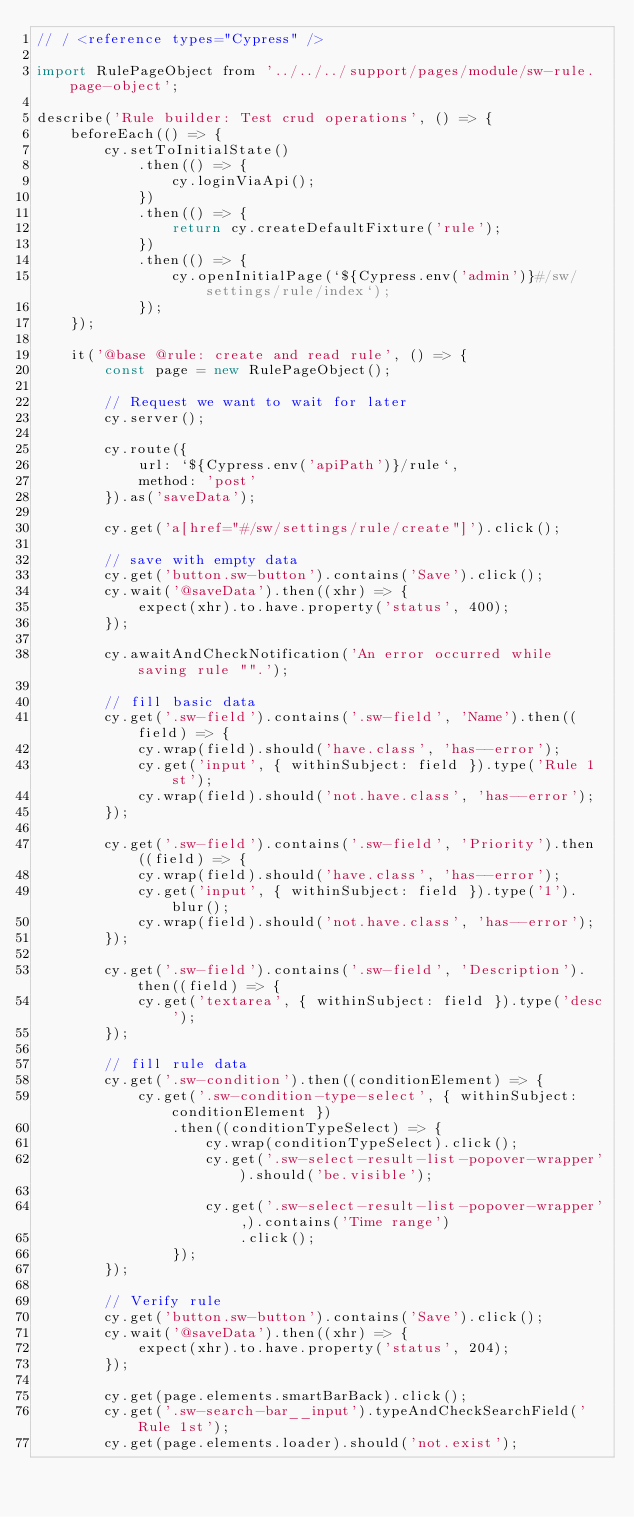<code> <loc_0><loc_0><loc_500><loc_500><_JavaScript_>// / <reference types="Cypress" />

import RulePageObject from '../../../support/pages/module/sw-rule.page-object';

describe('Rule builder: Test crud operations', () => {
    beforeEach(() => {
        cy.setToInitialState()
            .then(() => {
                cy.loginViaApi();
            })
            .then(() => {
                return cy.createDefaultFixture('rule');
            })
            .then(() => {
                cy.openInitialPage(`${Cypress.env('admin')}#/sw/settings/rule/index`);
            });
    });

    it('@base @rule: create and read rule', () => {
        const page = new RulePageObject();

        // Request we want to wait for later
        cy.server();

        cy.route({
            url: `${Cypress.env('apiPath')}/rule`,
            method: 'post'
        }).as('saveData');

        cy.get('a[href="#/sw/settings/rule/create"]').click();

        // save with empty data
        cy.get('button.sw-button').contains('Save').click();
        cy.wait('@saveData').then((xhr) => {
            expect(xhr).to.have.property('status', 400);
        });

        cy.awaitAndCheckNotification('An error occurred while saving rule "".');

        // fill basic data
        cy.get('.sw-field').contains('.sw-field', 'Name').then((field) => {
            cy.wrap(field).should('have.class', 'has--error');
            cy.get('input', { withinSubject: field }).type('Rule 1st');
            cy.wrap(field).should('not.have.class', 'has--error');
        });

        cy.get('.sw-field').contains('.sw-field', 'Priority').then((field) => {
            cy.wrap(field).should('have.class', 'has--error');
            cy.get('input', { withinSubject: field }).type('1').blur();
            cy.wrap(field).should('not.have.class', 'has--error');
        });

        cy.get('.sw-field').contains('.sw-field', 'Description').then((field) => {
            cy.get('textarea', { withinSubject: field }).type('desc');
        });

        // fill rule data
        cy.get('.sw-condition').then((conditionElement) => {
            cy.get('.sw-condition-type-select', { withinSubject: conditionElement })
                .then((conditionTypeSelect) => {
                    cy.wrap(conditionTypeSelect).click();
                    cy.get('.sw-select-result-list-popover-wrapper').should('be.visible');

                    cy.get('.sw-select-result-list-popover-wrapper',).contains('Time range')
                        .click();
                });
        });

        // Verify rule
        cy.get('button.sw-button').contains('Save').click();
        cy.wait('@saveData').then((xhr) => {
            expect(xhr).to.have.property('status', 204);
        });

        cy.get(page.elements.smartBarBack).click();
        cy.get('.sw-search-bar__input').typeAndCheckSearchField('Rule 1st');
        cy.get(page.elements.loader).should('not.exist');</code> 